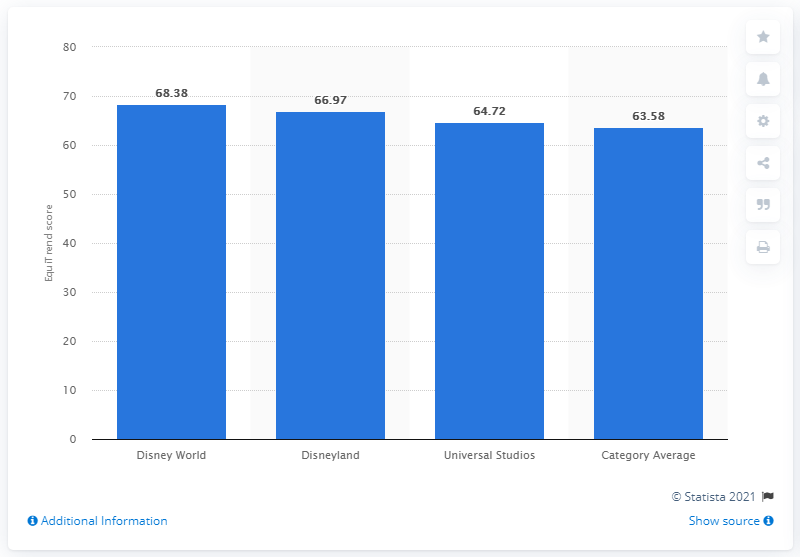Mention a couple of crucial points in this snapshot. In 2012, Disney World received a EquiTrend score of 68.38, indicating high levels of public awareness, appeal, and interest in the theme park. 